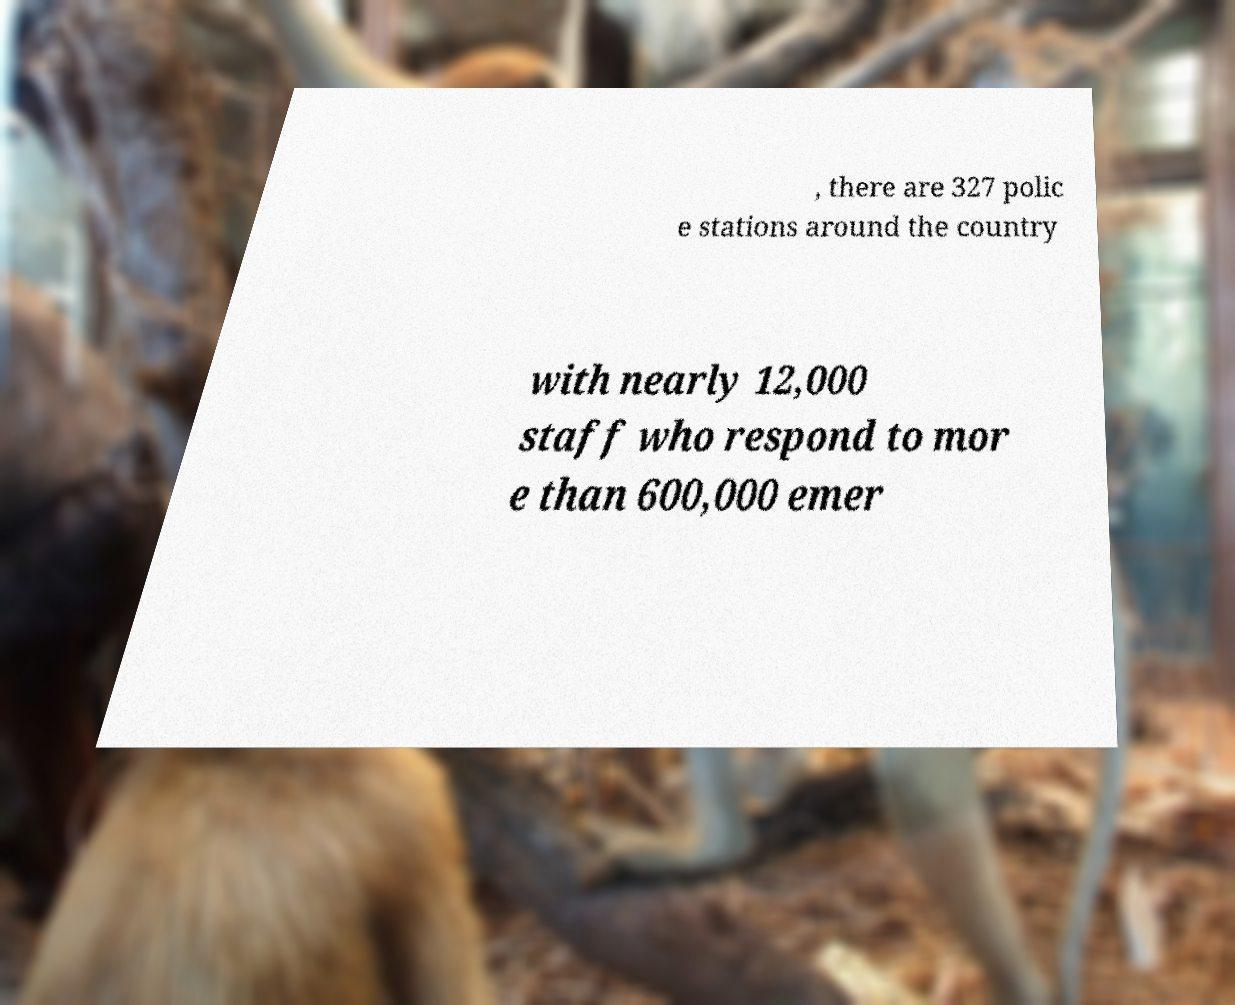Please identify and transcribe the text found in this image. , there are 327 polic e stations around the country with nearly 12,000 staff who respond to mor e than 600,000 emer 